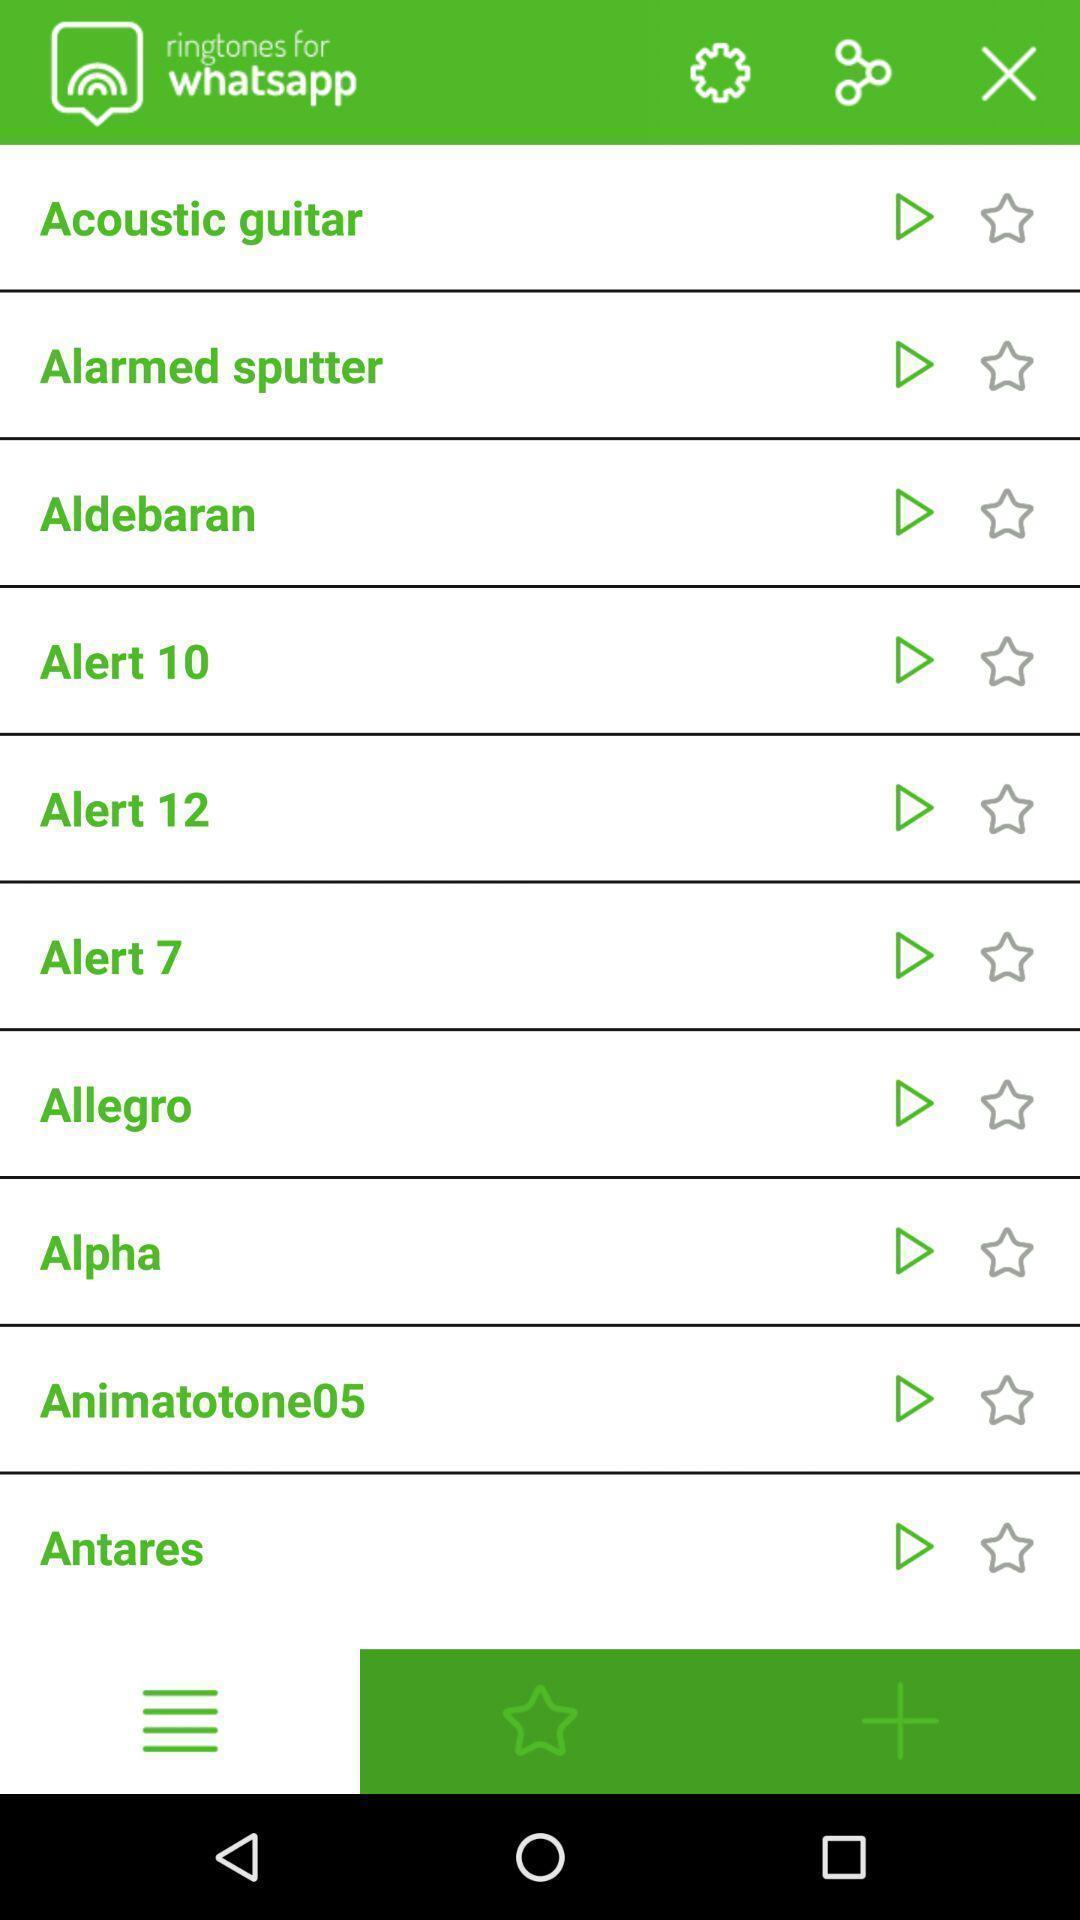Summarize the information in this screenshot. Screen displaying a list of ringtones information. 